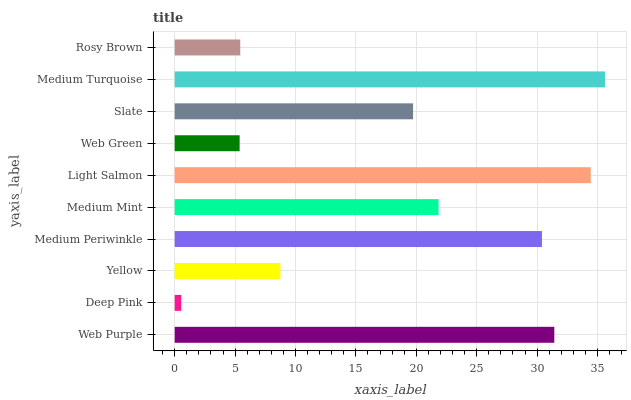Is Deep Pink the minimum?
Answer yes or no. Yes. Is Medium Turquoise the maximum?
Answer yes or no. Yes. Is Yellow the minimum?
Answer yes or no. No. Is Yellow the maximum?
Answer yes or no. No. Is Yellow greater than Deep Pink?
Answer yes or no. Yes. Is Deep Pink less than Yellow?
Answer yes or no. Yes. Is Deep Pink greater than Yellow?
Answer yes or no. No. Is Yellow less than Deep Pink?
Answer yes or no. No. Is Medium Mint the high median?
Answer yes or no. Yes. Is Slate the low median?
Answer yes or no. Yes. Is Medium Turquoise the high median?
Answer yes or no. No. Is Medium Turquoise the low median?
Answer yes or no. No. 